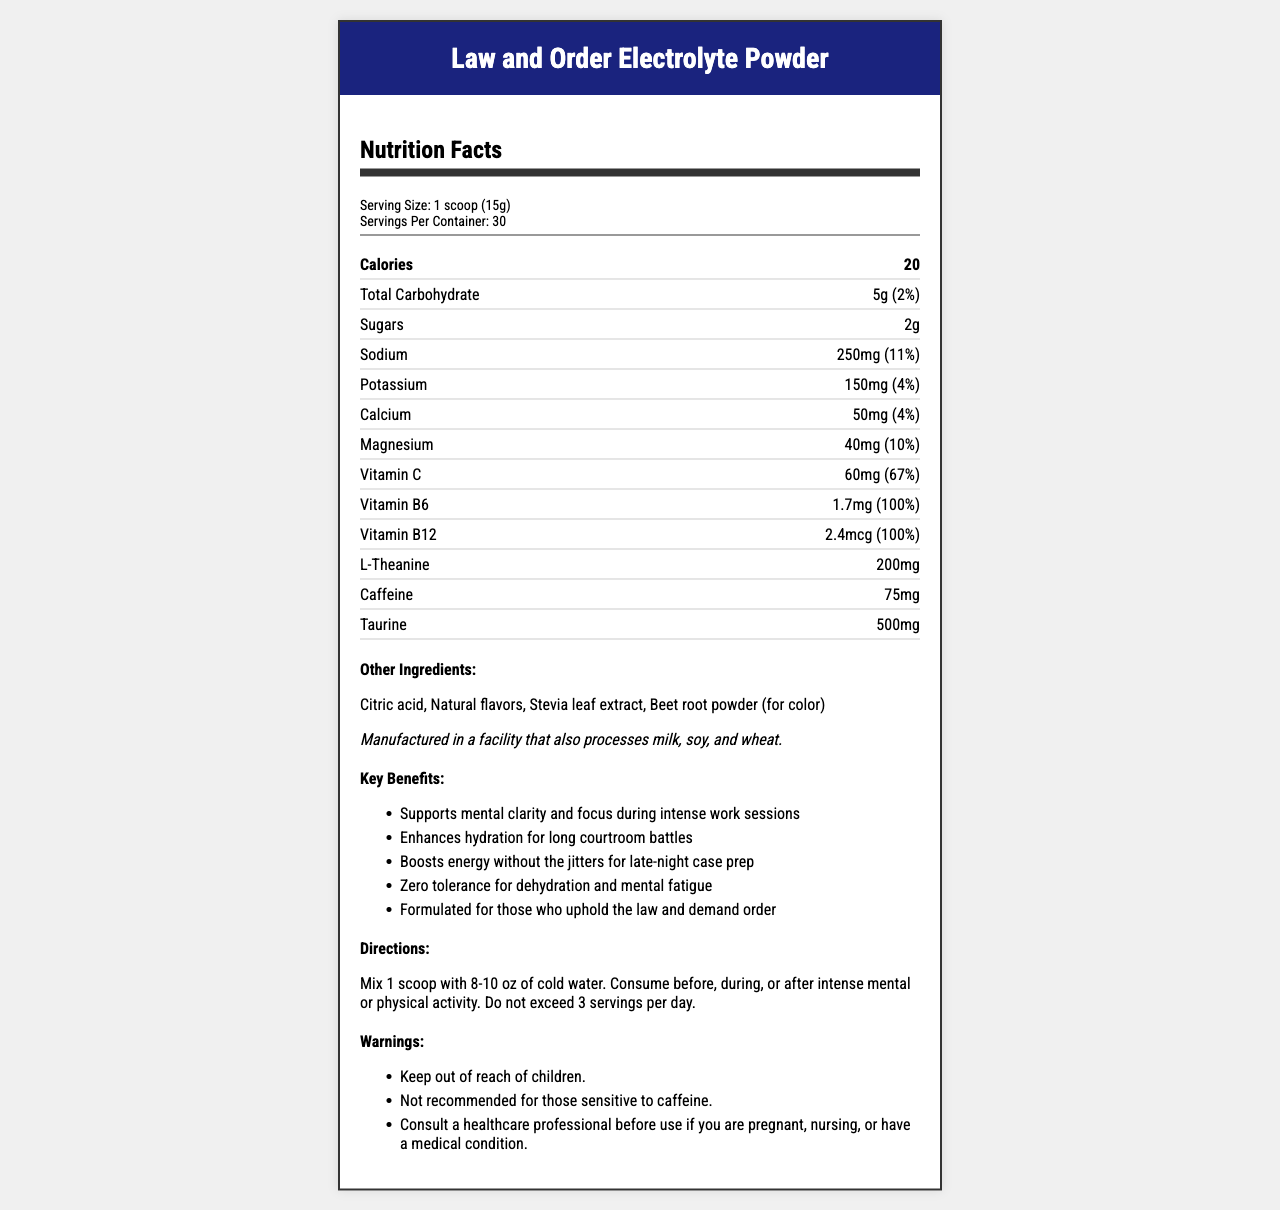what is the serving size of the Law and Order Electrolyte Powder? The document lists the serving size as "1 scoop (15g)" in the serving information.
Answer: 1 scoop (15g) how many calories does one serving contain? The document specifies that one serving contains 20 calories.
Answer: 20 what are the other ingredients in this product? The section labeled "Other Ingredients" lists these specific components.
Answer: Citric acid, Natural flavors, Stevia leaf extract, Beet root powder (for color) what is the amount of caffeine per serving? Under the nutrient detailed section, caffeine is listed with an amount of 75mg per serving.
Answer: 75mg what is the daily value percentage of vitamin c per serving? The document indicates that the daily value percentage for Vitamin C per serving is 67%.
Answer: 67% what are the key benefits of the electrolyte powder? The section labeled "Key Benefits" lists these specific claims.
Answer: Supports mental clarity and focus during intense work sessions, Enhances hydration for long courtroom battles, Boosts energy without the jitters for late-night case prep, Zero tolerance for dehydration and mental fatigue, Formulated for those who uphold the law and demand order how much sodium is in one serving, and is this a high amount? The document states that one serving contains 250mg of sodium which represents 11% of the daily value, a significant amount for a single serving.
Answer: 250mg; Yes, it's 11% of the daily value, which is relatively high. what is the recommended daily limit of servings for this product? The directions explicitly state not to exceed 3 servings per day.
Answer: 3 servings which vitamin is present in 100% of the daily value? A. Vitamin C B. Vitamin D C. Vitamin B6 D. Vitamin B12 The document shows that Vitamin B6 is present in 100% of the daily value per serving.
Answer: C. Vitamin B6 what is the main source of color in this electrolyte powder? The list of "Other Ingredients" mentions Beet root powder is used for color.
Answer: Beet root powder is this product free of allergens? The allergen information states that it is manufactured in a facility that processes milk, soy, and wheat, implying potential allergen exposure.
Answer: No what is the primary benefit related to hydration? One of the key benefits highlighted is that it enhances hydration, particularly useful for prolonged courtroom activities.
Answer: Enhances hydration for long courtroom battles what overall purpose does this product serve? Reading through the marketing claims section provides insights into the product's overall purpose, which caters explicitly to professionals in high-stress, demanding fields, particularly those in law enforcement or legal professions.
Answer: The product is designed to support mental clarity and focus, enhance hydration, boost energy without jitters, and prevent dehydration and mental fatigue, making it ideal for high-stress environments like law and order settings. does this product contain protein? The document does not provide information on protein content.
Answer: Cannot be determined describe the main idea of the document. The document is structured to provide comprehensive information about the product, highlighting its nutritional content and specific advantages for mental and physical performance. The marketing claims are tailored to stress the benefits for those in demanding careers, which aligns with the product's branding and target demographic.
Answer: The document details the nutritional information, key benefits, directions, warnings, and ingredients of the Law and Order Electrolyte Powder, emphasizing its hydration benefits and mental clarity boosters, specifically targeted at individuals in high-stress professions like law enforcement and legal fields. 